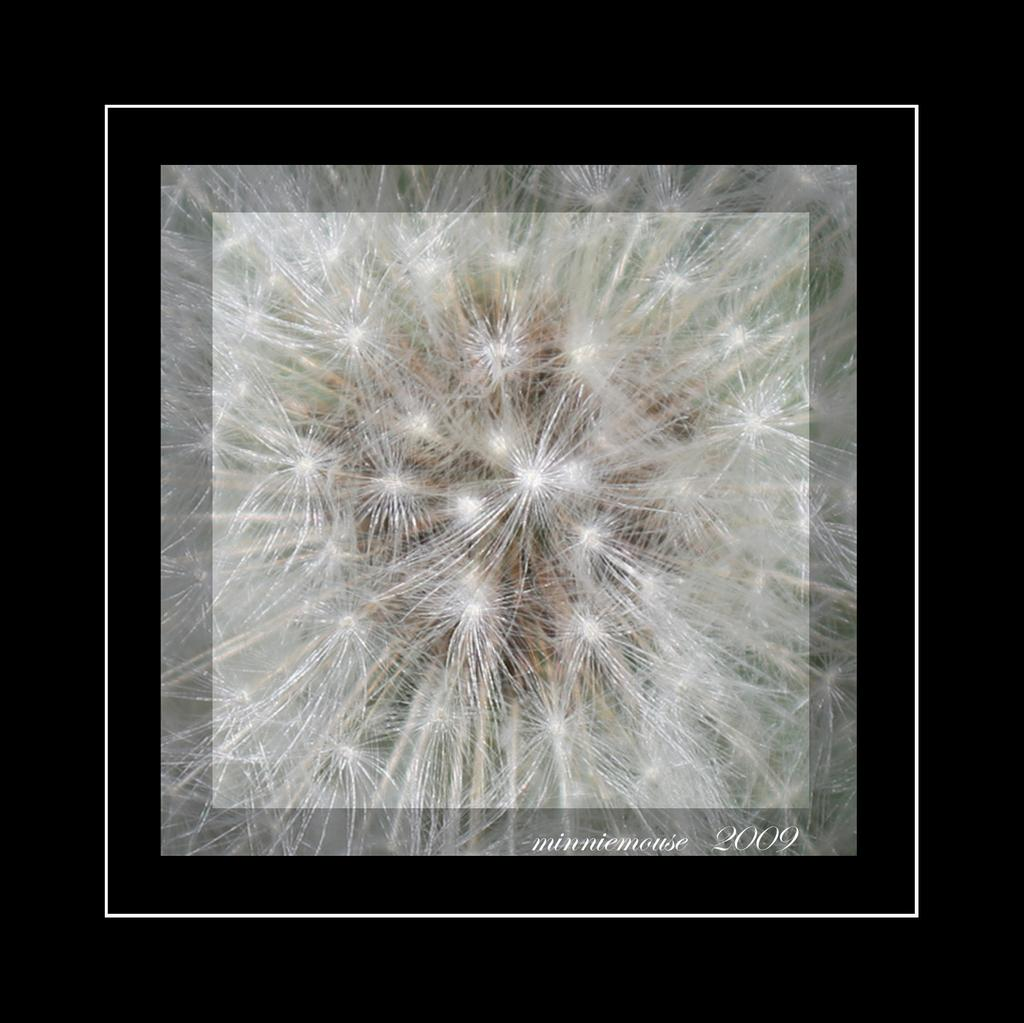What is the main subject in the center of the image? There are white color things in the center of the image. What can be found in the bottom right of the image? There is something written in the bottom right of the image. What color is the background of the image? The sides of the image appear to be black. How does the fork expand in the image? There is no fork present in the image, so it cannot expand. 